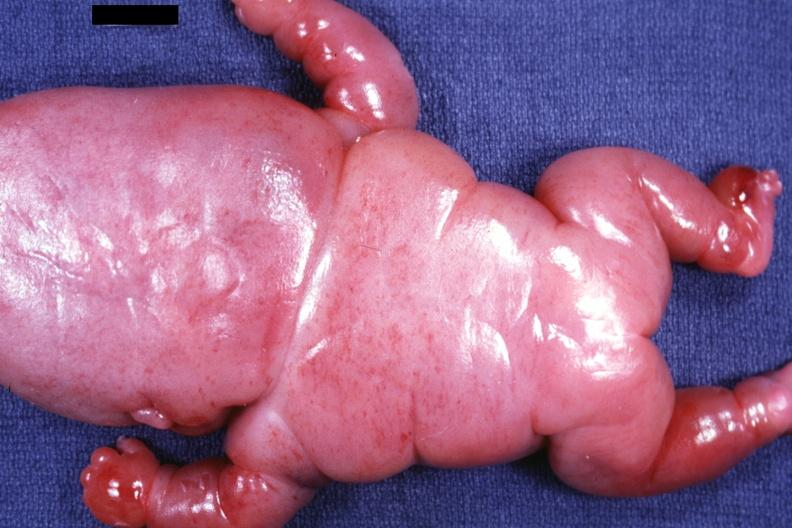s leiomyosarcoma present?
Answer the question using a single word or phrase. No 